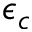Convert formula to latex. <formula><loc_0><loc_0><loc_500><loc_500>\epsilon _ { c }</formula> 